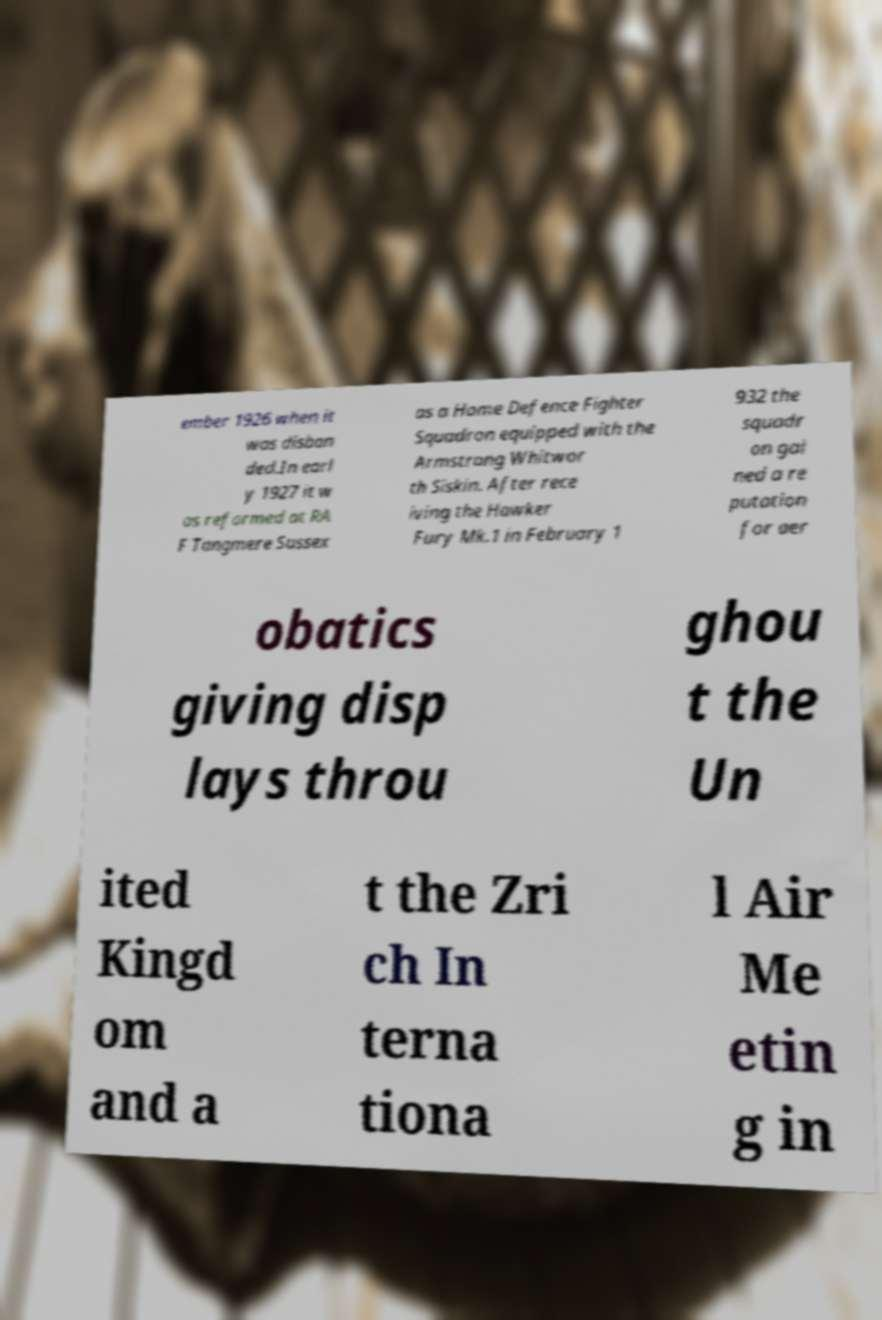Can you accurately transcribe the text from the provided image for me? ember 1926 when it was disban ded.In earl y 1927 it w as reformed at RA F Tangmere Sussex as a Home Defence Fighter Squadron equipped with the Armstrong Whitwor th Siskin. After rece iving the Hawker Fury Mk.1 in February 1 932 the squadr on gai ned a re putation for aer obatics giving disp lays throu ghou t the Un ited Kingd om and a t the Zri ch In terna tiona l Air Me etin g in 